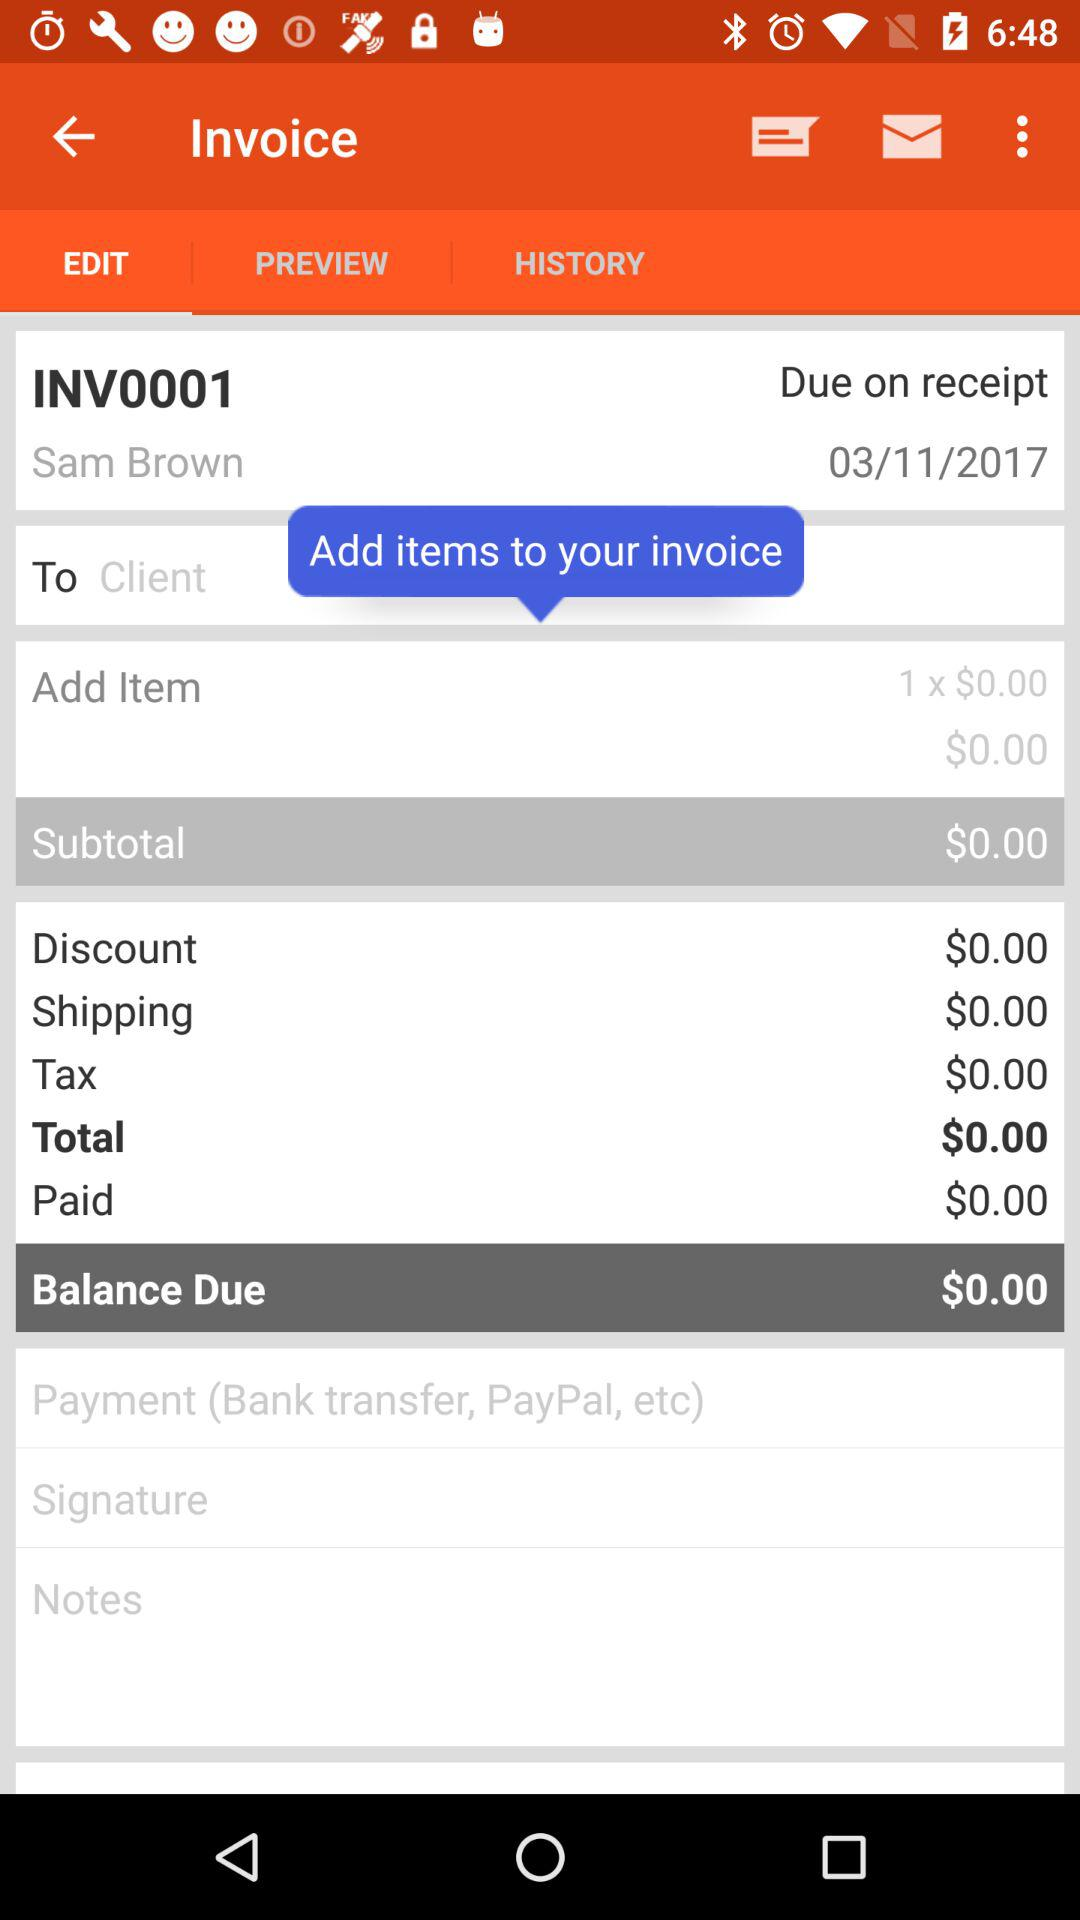How much is the total due?
Answer the question using a single word or phrase. $0.00 